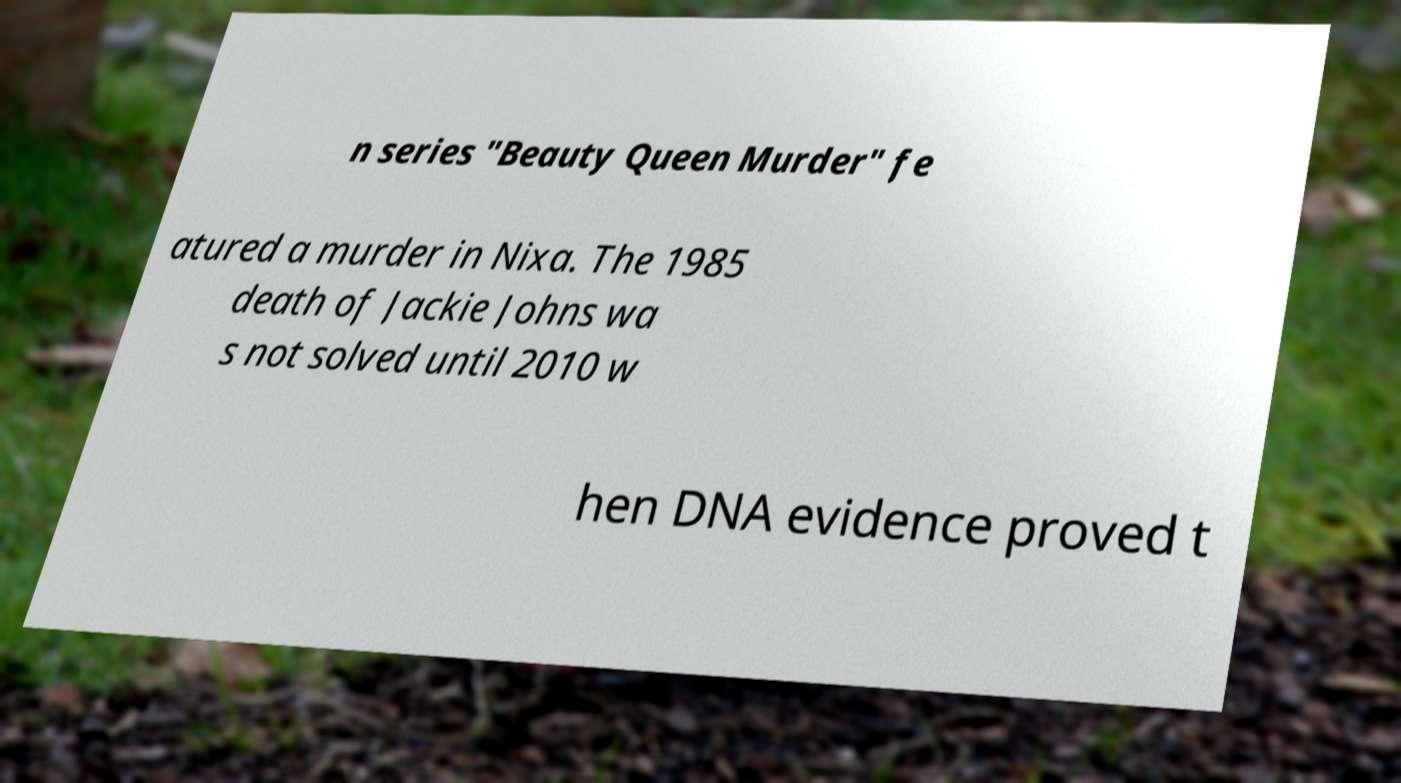For documentation purposes, I need the text within this image transcribed. Could you provide that? n series "Beauty Queen Murder" fe atured a murder in Nixa. The 1985 death of Jackie Johns wa s not solved until 2010 w hen DNA evidence proved t 